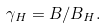Convert formula to latex. <formula><loc_0><loc_0><loc_500><loc_500>\gamma _ { H } = B / B _ { H } .</formula> 